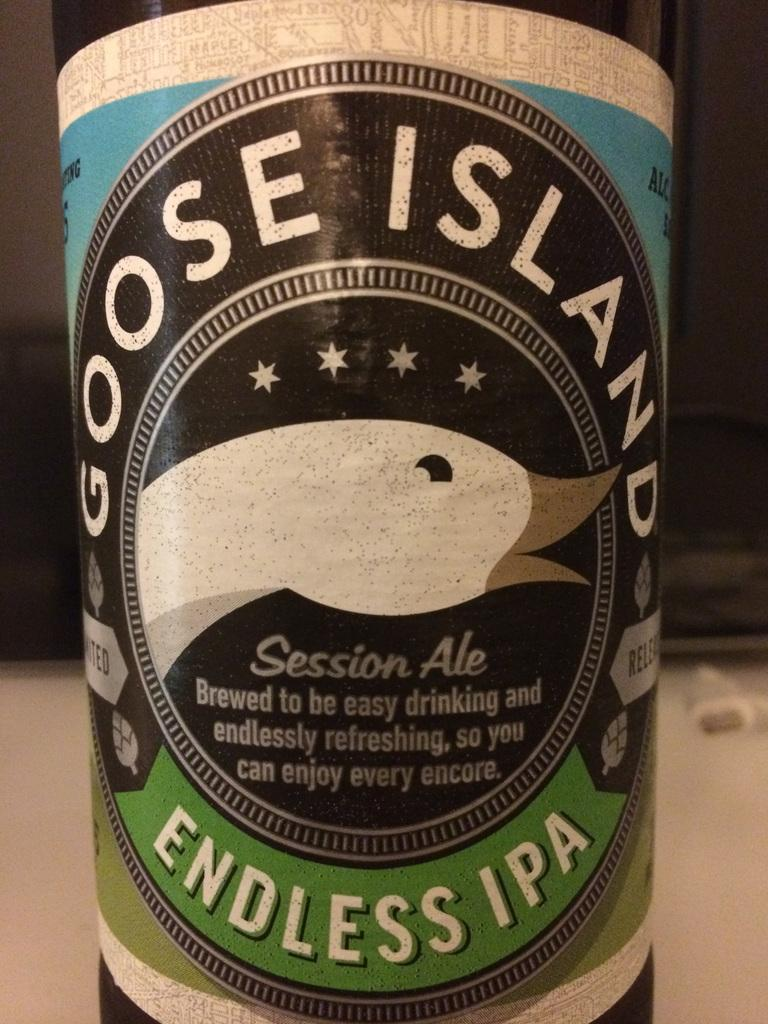<image>
Write a terse but informative summary of the picture. A close up of a Goose Island Endless IPA berr bottle. 